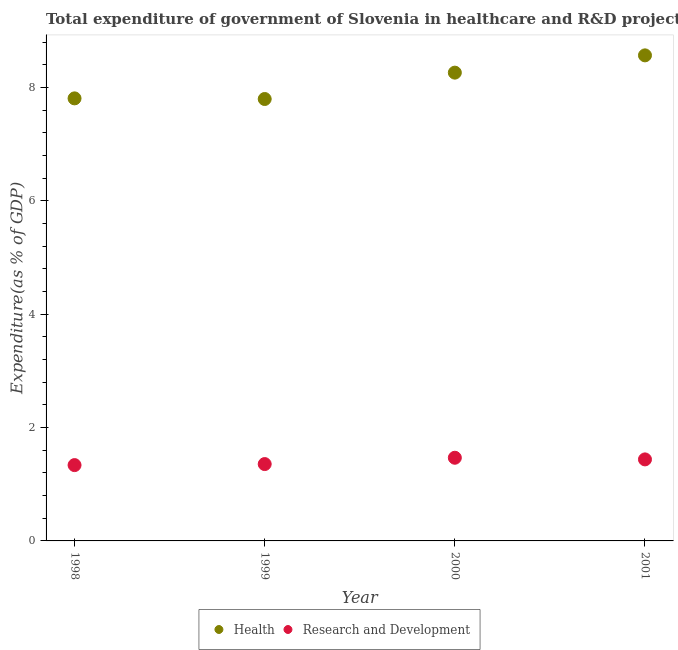How many different coloured dotlines are there?
Your answer should be very brief. 2. What is the expenditure in healthcare in 2001?
Your answer should be very brief. 8.57. Across all years, what is the maximum expenditure in r&d?
Offer a terse response. 1.47. Across all years, what is the minimum expenditure in healthcare?
Offer a terse response. 7.8. In which year was the expenditure in r&d maximum?
Ensure brevity in your answer.  2000. What is the total expenditure in r&d in the graph?
Provide a succinct answer. 5.6. What is the difference between the expenditure in healthcare in 1998 and that in 2001?
Give a very brief answer. -0.76. What is the difference between the expenditure in r&d in 1999 and the expenditure in healthcare in 2000?
Give a very brief answer. -6.91. What is the average expenditure in r&d per year?
Your answer should be compact. 1.4. In the year 1999, what is the difference between the expenditure in r&d and expenditure in healthcare?
Make the answer very short. -6.44. What is the ratio of the expenditure in healthcare in 1998 to that in 1999?
Make the answer very short. 1. Is the expenditure in r&d in 1998 less than that in 2001?
Your answer should be very brief. Yes. What is the difference between the highest and the second highest expenditure in healthcare?
Offer a very short reply. 0.3. What is the difference between the highest and the lowest expenditure in healthcare?
Keep it short and to the point. 0.77. How many years are there in the graph?
Your response must be concise. 4. Are the values on the major ticks of Y-axis written in scientific E-notation?
Make the answer very short. No. Does the graph contain any zero values?
Provide a succinct answer. No. Where does the legend appear in the graph?
Keep it short and to the point. Bottom center. How are the legend labels stacked?
Make the answer very short. Horizontal. What is the title of the graph?
Your answer should be very brief. Total expenditure of government of Slovenia in healthcare and R&D projects. Does "Ages 15-24" appear as one of the legend labels in the graph?
Provide a succinct answer. No. What is the label or title of the X-axis?
Offer a terse response. Year. What is the label or title of the Y-axis?
Give a very brief answer. Expenditure(as % of GDP). What is the Expenditure(as % of GDP) in Health in 1998?
Your answer should be compact. 7.81. What is the Expenditure(as % of GDP) in Research and Development in 1998?
Your response must be concise. 1.34. What is the Expenditure(as % of GDP) in Health in 1999?
Provide a succinct answer. 7.8. What is the Expenditure(as % of GDP) in Research and Development in 1999?
Give a very brief answer. 1.36. What is the Expenditure(as % of GDP) in Health in 2000?
Your answer should be compact. 8.26. What is the Expenditure(as % of GDP) of Research and Development in 2000?
Your answer should be compact. 1.47. What is the Expenditure(as % of GDP) in Health in 2001?
Make the answer very short. 8.57. What is the Expenditure(as % of GDP) in Research and Development in 2001?
Provide a short and direct response. 1.44. Across all years, what is the maximum Expenditure(as % of GDP) in Health?
Make the answer very short. 8.57. Across all years, what is the maximum Expenditure(as % of GDP) of Research and Development?
Offer a very short reply. 1.47. Across all years, what is the minimum Expenditure(as % of GDP) of Health?
Provide a succinct answer. 7.8. Across all years, what is the minimum Expenditure(as % of GDP) of Research and Development?
Give a very brief answer. 1.34. What is the total Expenditure(as % of GDP) of Health in the graph?
Keep it short and to the point. 32.44. What is the total Expenditure(as % of GDP) in Research and Development in the graph?
Give a very brief answer. 5.6. What is the difference between the Expenditure(as % of GDP) in Health in 1998 and that in 1999?
Your response must be concise. 0.01. What is the difference between the Expenditure(as % of GDP) in Research and Development in 1998 and that in 1999?
Provide a short and direct response. -0.02. What is the difference between the Expenditure(as % of GDP) in Health in 1998 and that in 2000?
Offer a very short reply. -0.45. What is the difference between the Expenditure(as % of GDP) of Research and Development in 1998 and that in 2000?
Give a very brief answer. -0.13. What is the difference between the Expenditure(as % of GDP) of Health in 1998 and that in 2001?
Give a very brief answer. -0.76. What is the difference between the Expenditure(as % of GDP) of Research and Development in 1998 and that in 2001?
Offer a terse response. -0.1. What is the difference between the Expenditure(as % of GDP) in Health in 1999 and that in 2000?
Keep it short and to the point. -0.47. What is the difference between the Expenditure(as % of GDP) in Research and Development in 1999 and that in 2000?
Give a very brief answer. -0.11. What is the difference between the Expenditure(as % of GDP) of Health in 1999 and that in 2001?
Your response must be concise. -0.77. What is the difference between the Expenditure(as % of GDP) in Research and Development in 1999 and that in 2001?
Offer a very short reply. -0.08. What is the difference between the Expenditure(as % of GDP) in Health in 2000 and that in 2001?
Your response must be concise. -0.3. What is the difference between the Expenditure(as % of GDP) in Research and Development in 2000 and that in 2001?
Your response must be concise. 0.03. What is the difference between the Expenditure(as % of GDP) in Health in 1998 and the Expenditure(as % of GDP) in Research and Development in 1999?
Make the answer very short. 6.45. What is the difference between the Expenditure(as % of GDP) of Health in 1998 and the Expenditure(as % of GDP) of Research and Development in 2000?
Ensure brevity in your answer.  6.34. What is the difference between the Expenditure(as % of GDP) of Health in 1998 and the Expenditure(as % of GDP) of Research and Development in 2001?
Provide a short and direct response. 6.37. What is the difference between the Expenditure(as % of GDP) in Health in 1999 and the Expenditure(as % of GDP) in Research and Development in 2000?
Offer a terse response. 6.33. What is the difference between the Expenditure(as % of GDP) in Health in 1999 and the Expenditure(as % of GDP) in Research and Development in 2001?
Offer a terse response. 6.36. What is the difference between the Expenditure(as % of GDP) of Health in 2000 and the Expenditure(as % of GDP) of Research and Development in 2001?
Give a very brief answer. 6.83. What is the average Expenditure(as % of GDP) of Health per year?
Your response must be concise. 8.11. What is the average Expenditure(as % of GDP) in Research and Development per year?
Provide a short and direct response. 1.4. In the year 1998, what is the difference between the Expenditure(as % of GDP) in Health and Expenditure(as % of GDP) in Research and Development?
Your answer should be compact. 6.47. In the year 1999, what is the difference between the Expenditure(as % of GDP) in Health and Expenditure(as % of GDP) in Research and Development?
Your answer should be compact. 6.44. In the year 2000, what is the difference between the Expenditure(as % of GDP) of Health and Expenditure(as % of GDP) of Research and Development?
Provide a short and direct response. 6.8. In the year 2001, what is the difference between the Expenditure(as % of GDP) of Health and Expenditure(as % of GDP) of Research and Development?
Your response must be concise. 7.13. What is the ratio of the Expenditure(as % of GDP) in Research and Development in 1998 to that in 1999?
Ensure brevity in your answer.  0.99. What is the ratio of the Expenditure(as % of GDP) of Health in 1998 to that in 2000?
Your response must be concise. 0.95. What is the ratio of the Expenditure(as % of GDP) of Research and Development in 1998 to that in 2000?
Give a very brief answer. 0.91. What is the ratio of the Expenditure(as % of GDP) of Health in 1998 to that in 2001?
Give a very brief answer. 0.91. What is the ratio of the Expenditure(as % of GDP) of Research and Development in 1998 to that in 2001?
Your answer should be very brief. 0.93. What is the ratio of the Expenditure(as % of GDP) of Health in 1999 to that in 2000?
Give a very brief answer. 0.94. What is the ratio of the Expenditure(as % of GDP) in Research and Development in 1999 to that in 2000?
Keep it short and to the point. 0.92. What is the ratio of the Expenditure(as % of GDP) in Health in 1999 to that in 2001?
Provide a succinct answer. 0.91. What is the ratio of the Expenditure(as % of GDP) in Research and Development in 1999 to that in 2001?
Ensure brevity in your answer.  0.94. What is the ratio of the Expenditure(as % of GDP) of Health in 2000 to that in 2001?
Offer a very short reply. 0.96. What is the ratio of the Expenditure(as % of GDP) in Research and Development in 2000 to that in 2001?
Provide a succinct answer. 1.02. What is the difference between the highest and the second highest Expenditure(as % of GDP) in Health?
Your response must be concise. 0.3. What is the difference between the highest and the second highest Expenditure(as % of GDP) of Research and Development?
Give a very brief answer. 0.03. What is the difference between the highest and the lowest Expenditure(as % of GDP) of Health?
Give a very brief answer. 0.77. What is the difference between the highest and the lowest Expenditure(as % of GDP) of Research and Development?
Make the answer very short. 0.13. 